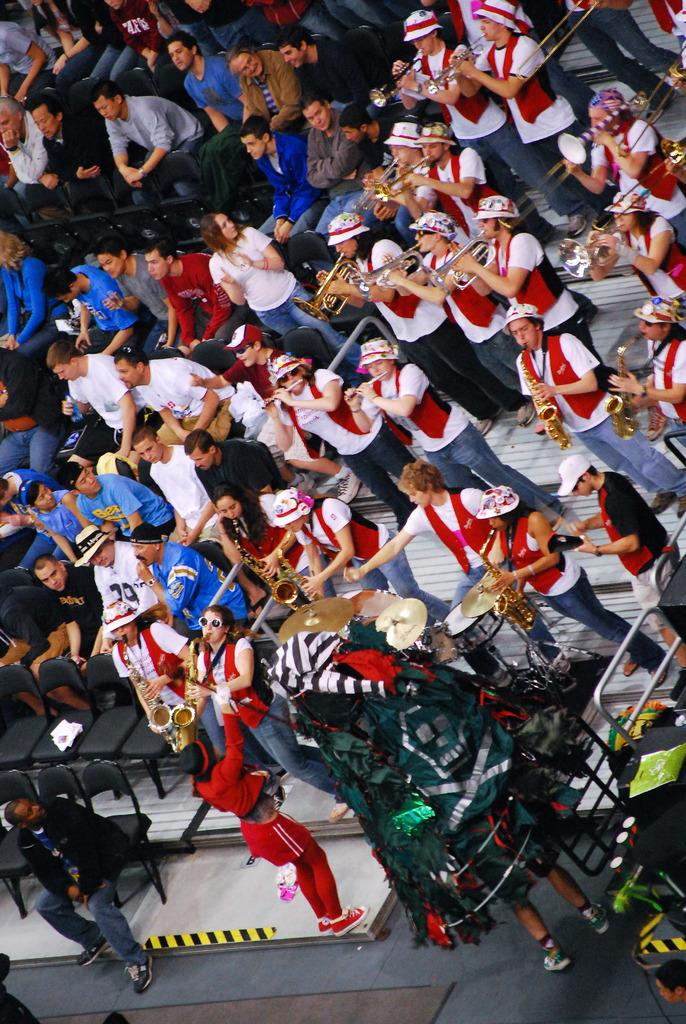What is happening in the image involving a group of people? There is a group of people in the image, and they are playing musical instruments. Can you describe the positions of the people in the image? Some people are sitting on chairs, while others are standing on steps. What might be the purpose of the steps in the image? The steps might be used for elevation or to create a tiered seating arrangement for the musicians. What type of sponge is being used by the people in the image? There is no sponge present in the image; the people are playing musical instruments. 